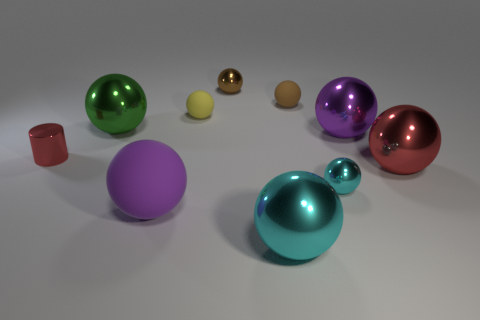Apart from spheres, there is another shape present; can you describe it and its relation to the spheres? Yes, amidst the array of spheres, there is a single red cube. Its sharp edges and flat surfaces contrast with the smooth, curved surfaces of the spheres, introducing a sense of diversity and breaking the uniformity of the shapes in the scene. It stands out due to its unique shape and color, adding variety to the overall composition. 